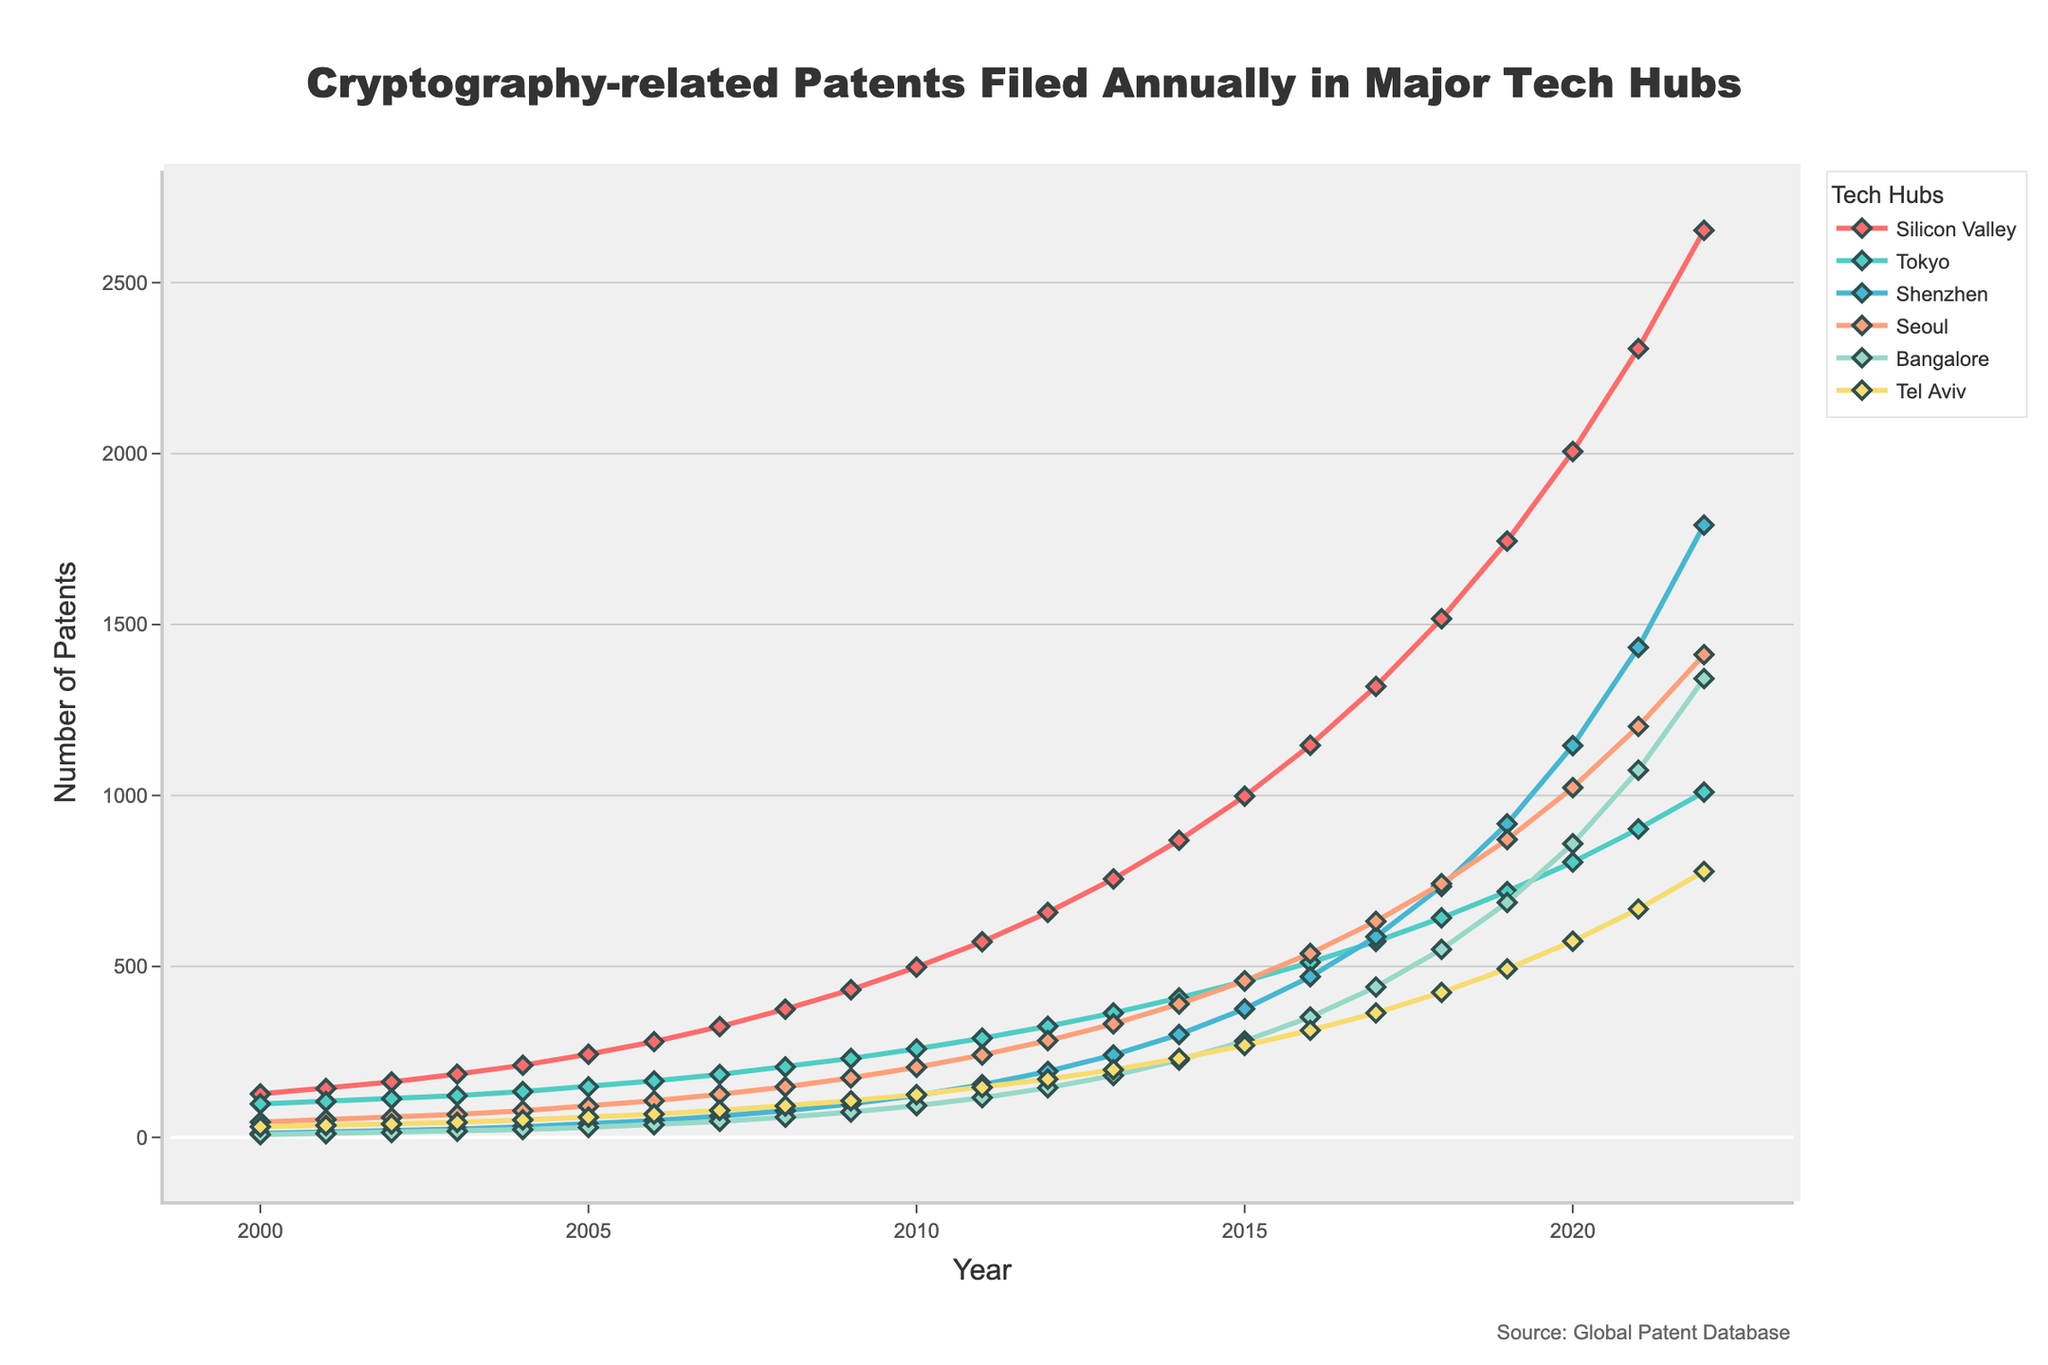what is the trend of cryptography-related patents filed in Silicon Valley from 2000 to 2022? The line for Silicon Valley starts at 127 in 2000 and rises steadily to 2653 in 2022. There is an upward trend in the number of patents filed annually.
Answer: upward trend which tech hub filed the most cryptography-related patents in 2022? In 2022, Silicon Valley has the highest value on the graph compared to other tech hubs, reaching 2653 patents, so it filed the most patents.
Answer: Silicon Valley comparing the number of patents filed in 2020 and 2010 in Seoul, what is the difference? In 2020, Seoul filed 1023 patents, and in 2010, it filed 205. The difference is 1023 - 205 = 818 patents.
Answer: 818 which three tech hubs show the largest increase in patents from 2000 to 2022? Observing the trends from the start to the end points in the graph, Silicon Valley, Shenzhen, and Seoul exhibit the largest increases. Silicon Valley rises from 127 to 2653, Shenzhen from 12 to 1791, and Seoul from 45 to 1412.
Answer: Silicon Valley, Shenzhen, Seoul by how much did the number of patents filed in Tokyo increase between 2015 and 2016? For Tokyo, the number of patents increases from 457 in 2015 to 512 in 2016. The increase is 512 - 457 = 55 patents.
Answer: 55 what is the visual difference in the trend lines between Bangalore and Tel Aviv? The trend lines for both Bangalore and Tel Aviv exhibit an upward trend but Bangalore's rise is steeper and reaches higher values from around 8 to 1342, while Tel Aviv goes from 31 to 778.
Answer: Bangalore's line is steeper which tech hub showed the most significant growth in patents filed from 2017 to 2021? By tracing the lines for the relevant years, Silicon Valley shows the most significant growth, rising from 1319 in 2017 to 2307 in 2021.
Answer: Silicon Valley what is the average number of patents filed by Tokyo in the first five years (2000-2004)? The values for Tokyo from 2000 to 2004 are 98, 105, 113, 122, and 134. The average is (98 + 105 + 113 + 122 + 134) / 5 = 114.4 patents.
Answer: 114.4 are there any noticeable dips in any of the tech hubs' patent filings trends? No noticeable dips are observed; all tech hubs exhibit consistent upward trends without significant decreases.
Answer: No how much more did Silicon Valley file than Tel Aviv in 2022? In 2022, Silicon Valley filed 2653 patents, and Tel Aviv filed 778. The difference is 2653 - 778 = 1875 patents.
Answer: 1875 